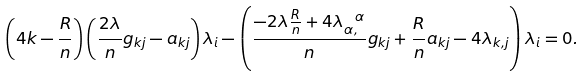<formula> <loc_0><loc_0><loc_500><loc_500>\left ( 4 k - \frac { R } { n } \right ) \left ( \frac { 2 \lambda } { n } g _ { k j } - a _ { k j } \right ) \lambda _ { i } - \left ( \frac { - 2 \lambda \frac { R } { n } + 4 \lambda _ { \alpha , } ^ { \ \alpha } } { n } g _ { k j } + \frac { R } { n } a _ { k j } - 4 \lambda _ { k , j } \right ) \lambda _ { i } = 0 .</formula> 